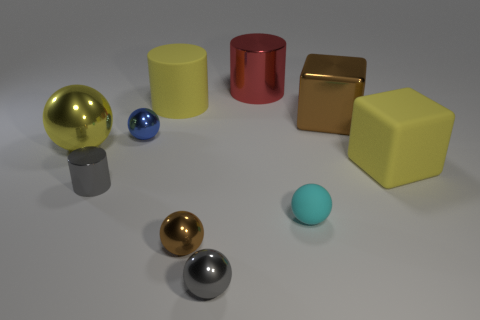There is a rubber cylinder; is it the same color as the large metallic object that is left of the large yellow rubber cylinder?
Your response must be concise. Yes. There is a brown thing on the left side of the gray shiny object right of the small gray cylinder; what shape is it?
Ensure brevity in your answer.  Sphere. What size is the matte object that is the same color as the large rubber cube?
Give a very brief answer. Large. Is the shape of the brown metal object that is to the left of the cyan rubber thing the same as  the small rubber object?
Make the answer very short. Yes. Are there more tiny cylinders that are on the left side of the big yellow rubber cylinder than small matte objects that are on the left side of the small cyan thing?
Make the answer very short. Yes. There is a gray thing that is in front of the tiny gray cylinder; what number of brown blocks are in front of it?
Keep it short and to the point. 0. What material is the ball that is the same color as the shiny block?
Provide a short and direct response. Metal. What number of other objects are there of the same color as the big matte cylinder?
Offer a very short reply. 2. There is a sphere that is behind the big metal object left of the blue object; what color is it?
Your response must be concise. Blue. Are there any other large rubber cylinders of the same color as the large rubber cylinder?
Offer a very short reply. No. 